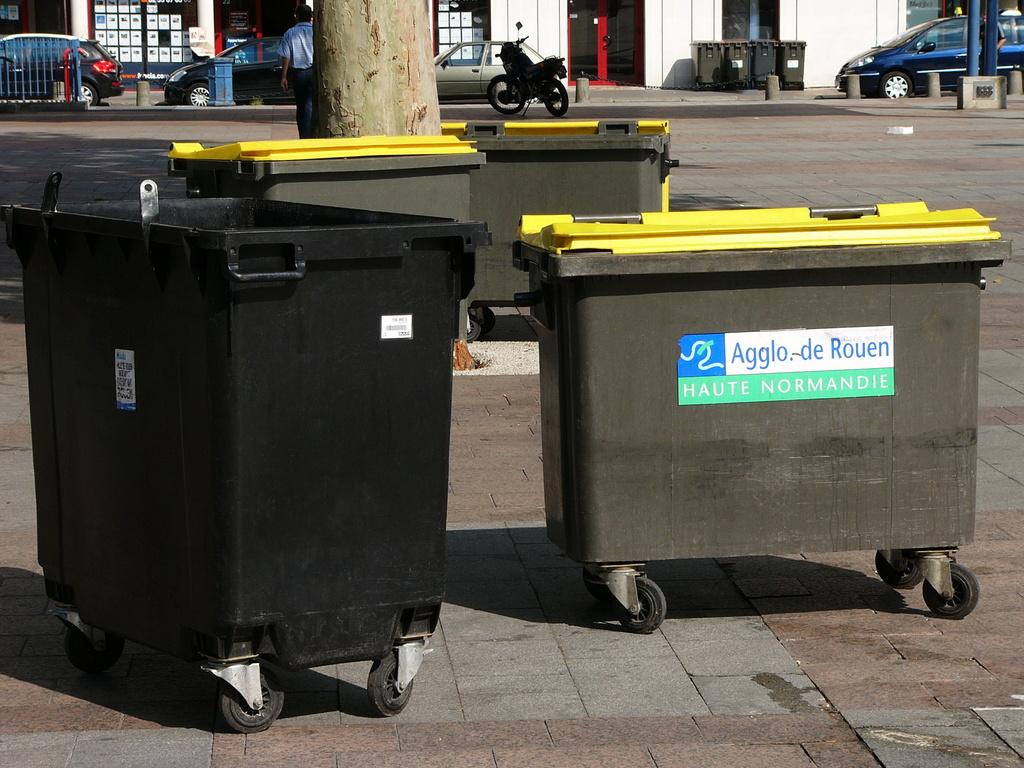Who is in charge of the waste management?
Your answer should be compact. Agglo-de rouen. Are there any numbers on the identification label?
Make the answer very short. No. 